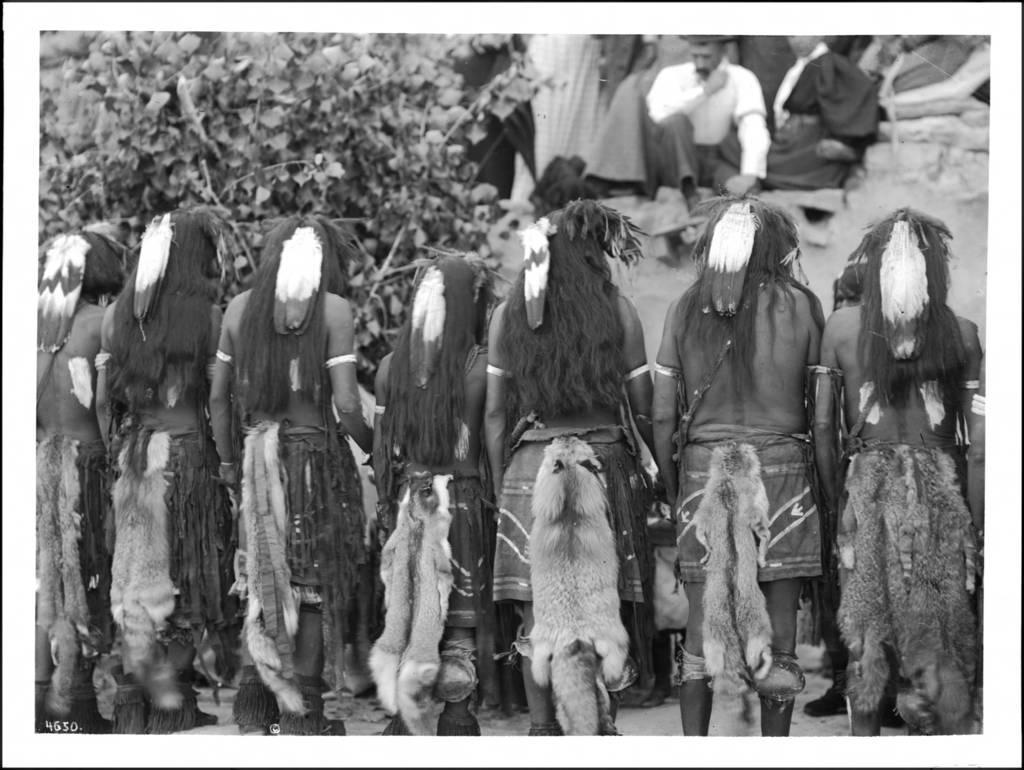Describe this image in one or two sentences. This picture describes about group of people, few are seated and few are standing, in front of them we can see a tree and it is a black and white photography. 